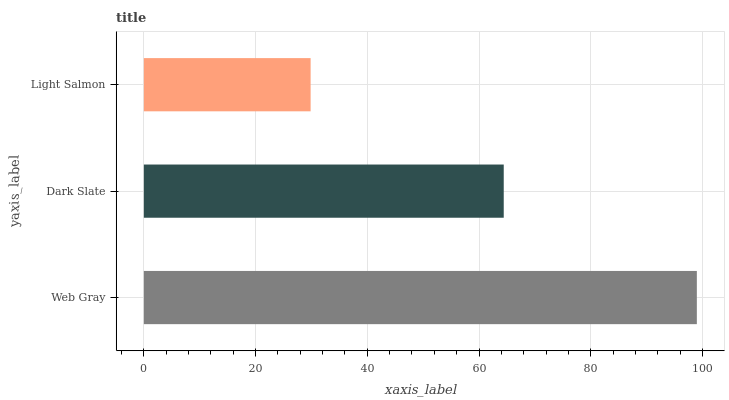Is Light Salmon the minimum?
Answer yes or no. Yes. Is Web Gray the maximum?
Answer yes or no. Yes. Is Dark Slate the minimum?
Answer yes or no. No. Is Dark Slate the maximum?
Answer yes or no. No. Is Web Gray greater than Dark Slate?
Answer yes or no. Yes. Is Dark Slate less than Web Gray?
Answer yes or no. Yes. Is Dark Slate greater than Web Gray?
Answer yes or no. No. Is Web Gray less than Dark Slate?
Answer yes or no. No. Is Dark Slate the high median?
Answer yes or no. Yes. Is Dark Slate the low median?
Answer yes or no. Yes. Is Web Gray the high median?
Answer yes or no. No. Is Web Gray the low median?
Answer yes or no. No. 